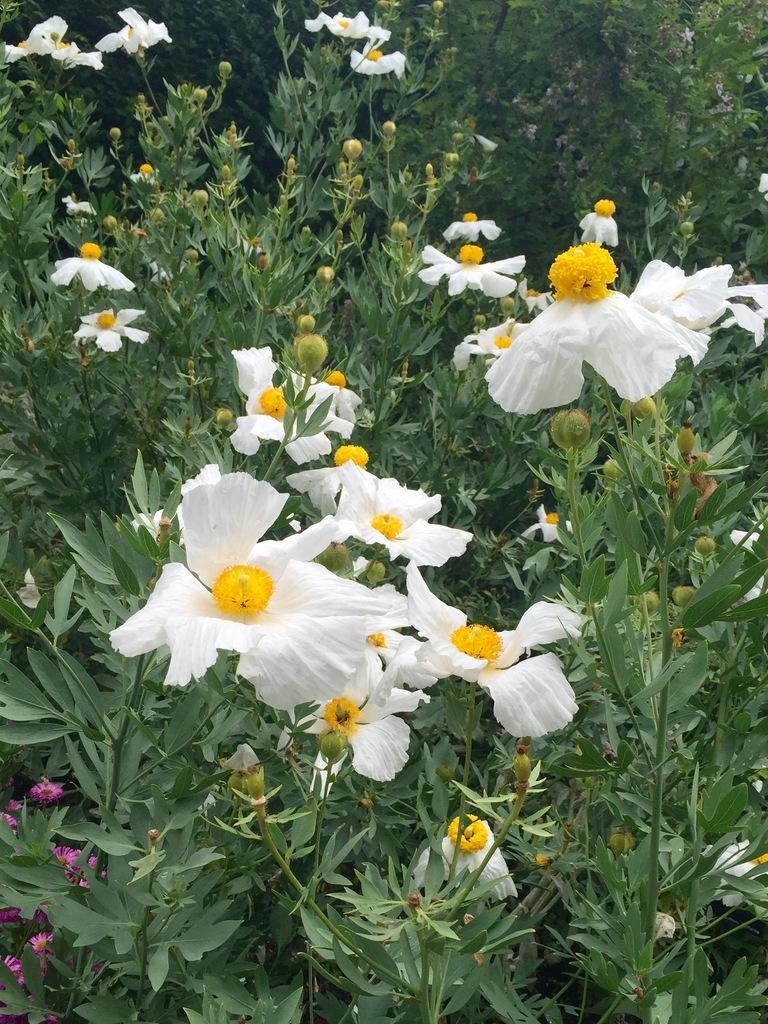What colors are the flowers in the image? The flowers in the image are white and pink. What part of the flowers are visible in the image? The flowers have stems in the image. What type of vegetation can be seen in the image besides flowers? There are trees visible in the image. Can you see the ocean in the image? No, the ocean is not present in the image. Is there a volleyball visible in the image? No, there is no volleyball present in the image. 